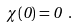Convert formula to latex. <formula><loc_0><loc_0><loc_500><loc_500>\chi ( 0 ) = 0 \ .</formula> 